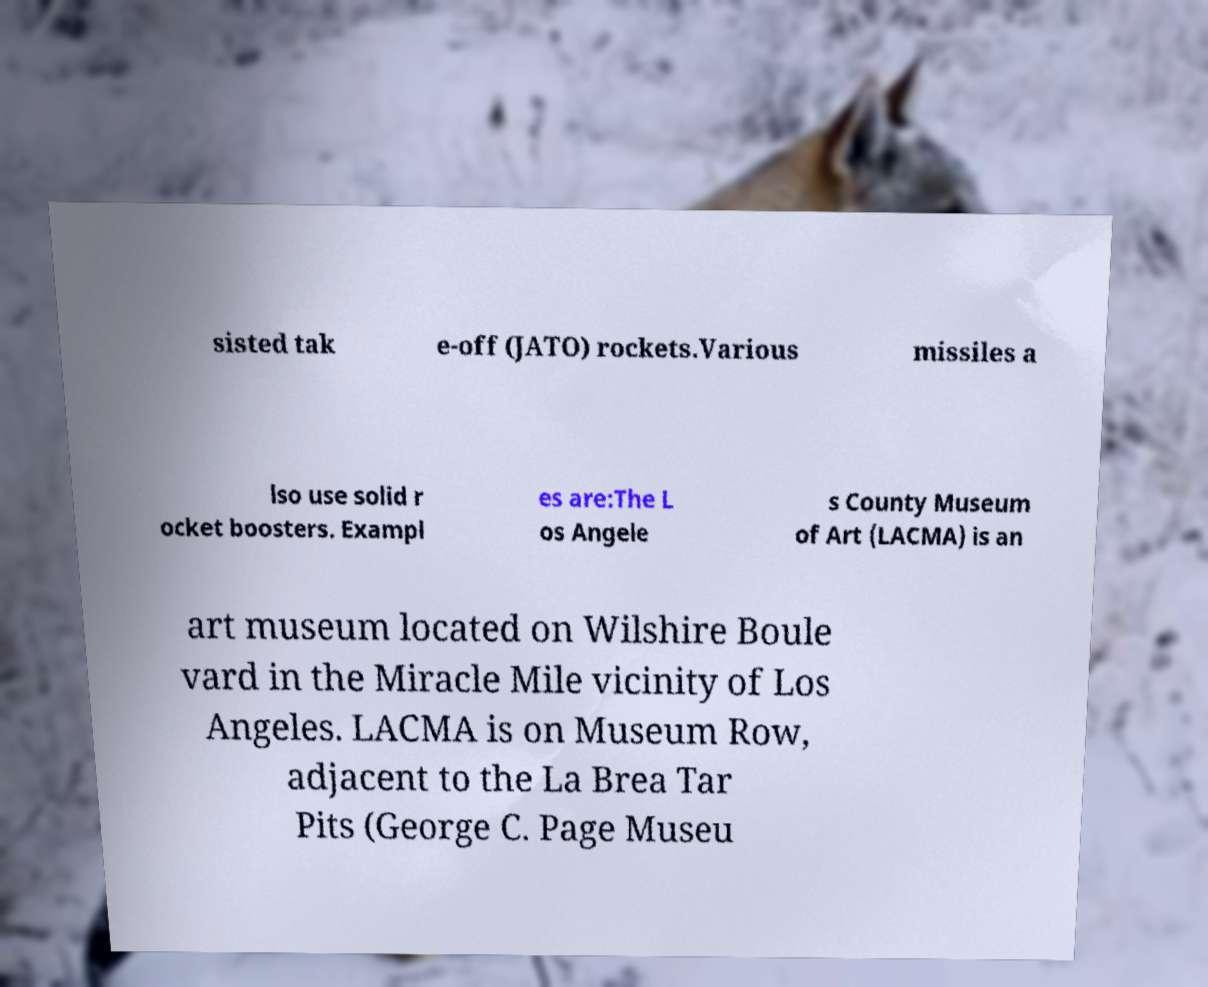Could you assist in decoding the text presented in this image and type it out clearly? sisted tak e-off (JATO) rockets.Various missiles a lso use solid r ocket boosters. Exampl es are:The L os Angele s County Museum of Art (LACMA) is an art museum located on Wilshire Boule vard in the Miracle Mile vicinity of Los Angeles. LACMA is on Museum Row, adjacent to the La Brea Tar Pits (George C. Page Museu 